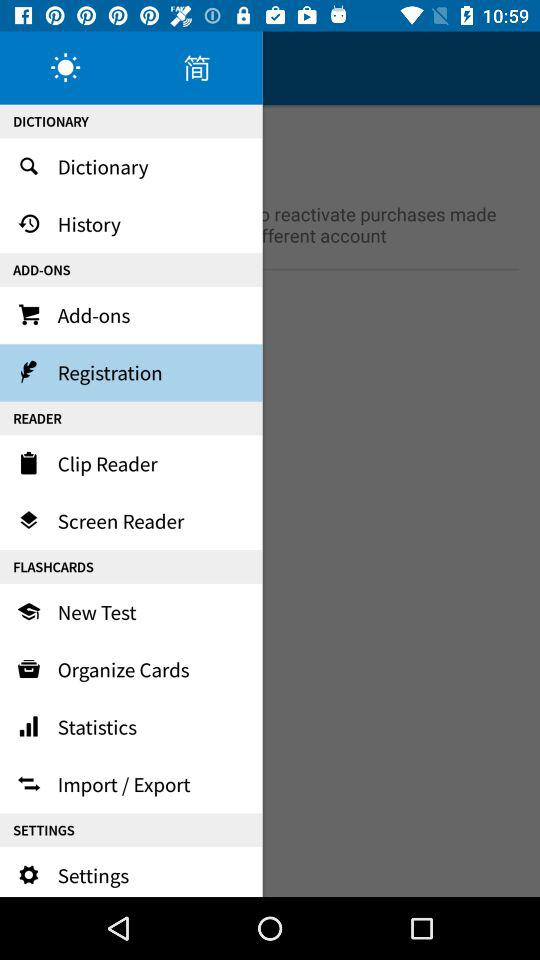Which option is selected? The highlighted option is "Registration". 